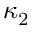<formula> <loc_0><loc_0><loc_500><loc_500>\kappa _ { 2 }</formula> 